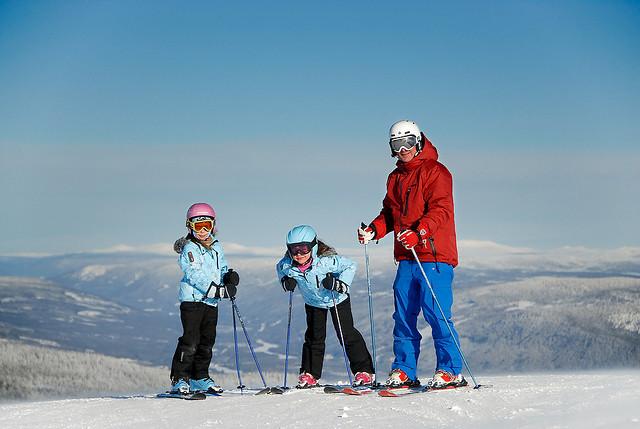What age is the kid to the left of the adult?
Quick response, please. 5. Is this a competition?
Short answer required. No. What are they wearing?
Be succinct. Snow gear. Which girl has a purple parka?
Give a very brief answer. 0. What is this man thinking?
Keep it brief. Fun. Are all the people wearing different colors?
Be succinct. No. Are these kids trying to learn to ski?
Short answer required. Yes. Are there clouds in the sky?
Quick response, please. Yes. What 4 colors make up 90 percent of the 2 females clothing?
Concise answer only. Blue. How many kids in this photo?
Concise answer only. 2. 